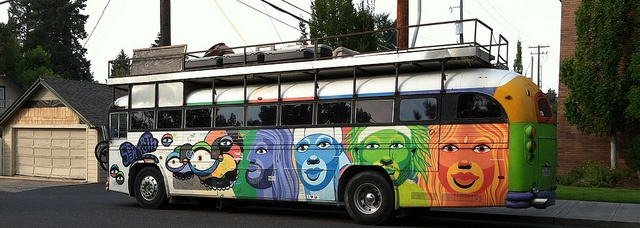Describe the objects in this image and their specific colors. I can see bus in ivory, black, gray, and darkgray tones in this image. 